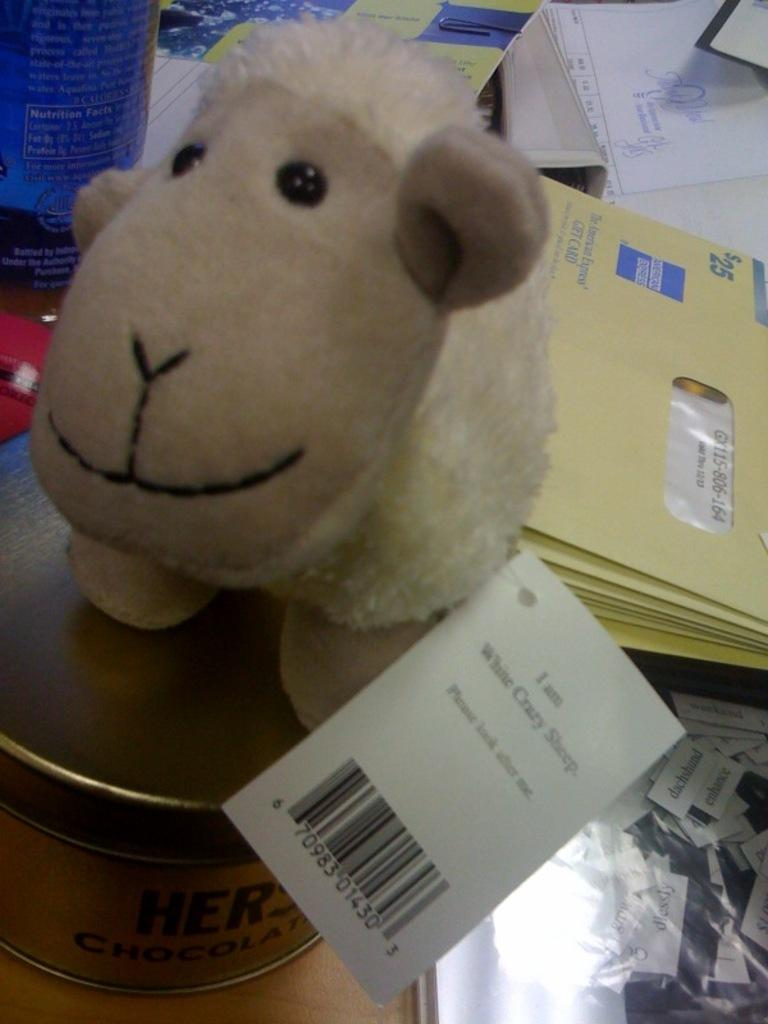What is the main object in the image? There is a doll in the image. What is located at the bottom of the image? There is a box at the bottom of the image. What can be seen in the background of the image? There are envelopes and papers in the background of the image. Where is the nearest stream to the doll in the image? There is no stream present in the image. How many clocks can be seen in the image? There are no clocks visible in the image. 